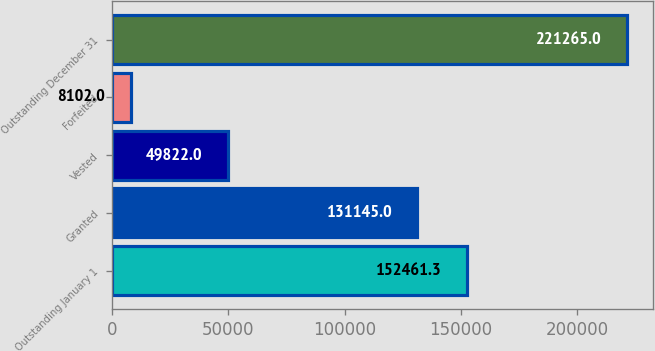<chart> <loc_0><loc_0><loc_500><loc_500><bar_chart><fcel>Outstanding January 1<fcel>Granted<fcel>Vested<fcel>Forfeited<fcel>Outstanding December 31<nl><fcel>152461<fcel>131145<fcel>49822<fcel>8102<fcel>221265<nl></chart> 